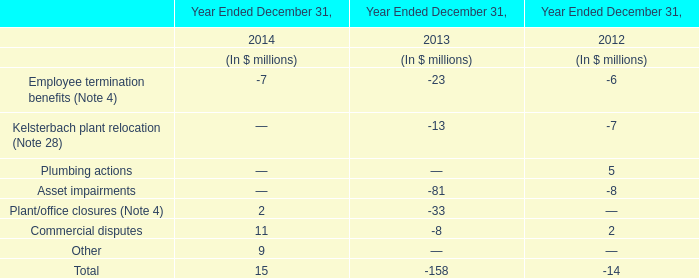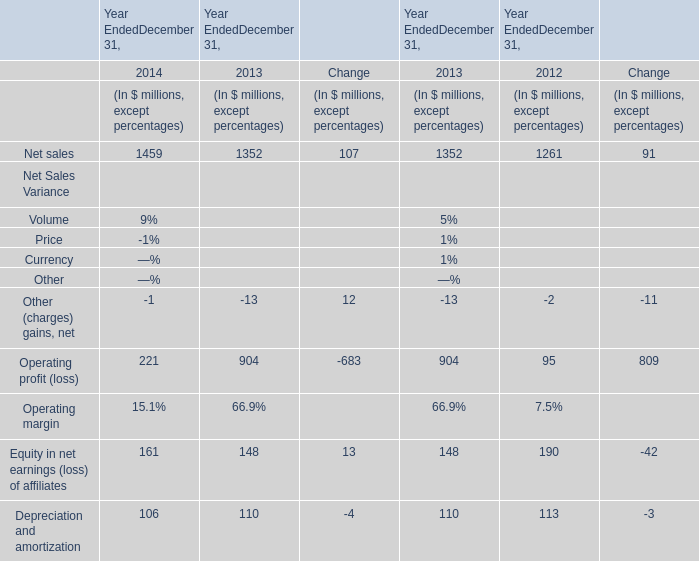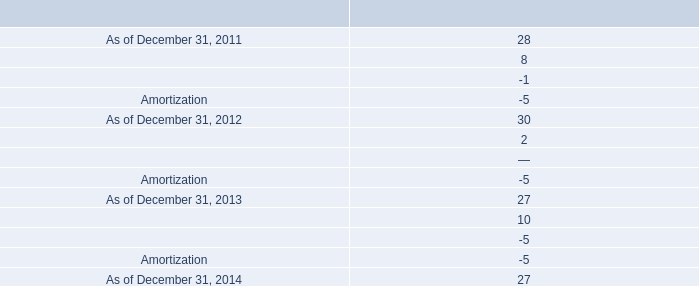What was the total amount of Net sales in 2014? (in million) 
Answer: 1459. 